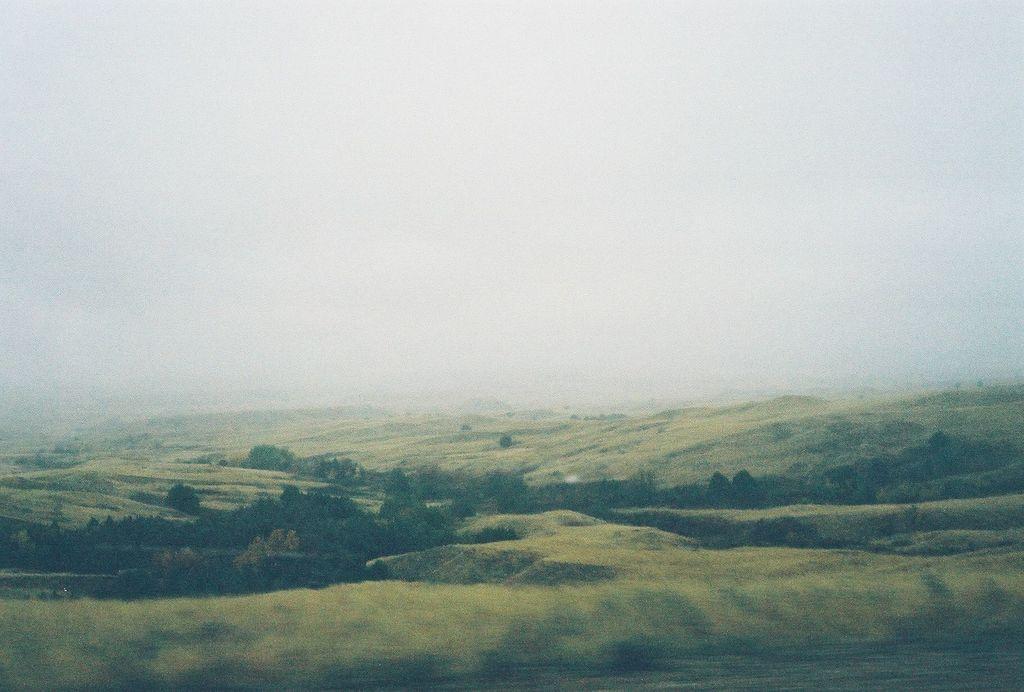In one or two sentences, can you explain what this image depicts? It is a beautiful scenery,there are plenty of trees and grass on the surface and the background is blurry. 